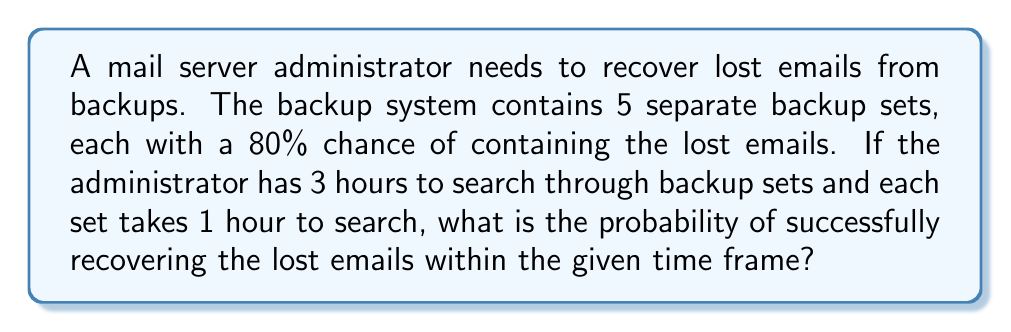Provide a solution to this math problem. Let's approach this step-by-step:

1) The administrator can search through 3 backup sets in the given time frame.

2) The probability of success for each backup set is 80% or 0.8.

3) The probability of failure for each backup set is 1 - 0.8 = 0.2 or 20%.

4) To calculate the probability of success within 3 hours, we need to find the probability of success in at least one of the three backup sets searched.

5) It's easier to calculate the probability of failure in all three sets and then subtract that from 1.

6) The probability of failure in all three sets:
   $$(0.2)^3 = 0.008$$

7) Therefore, the probability of success in at least one of the three sets is:
   $$1 - (0.2)^3 = 1 - 0.008 = 0.992$$

8) Convert to percentage:
   $$0.992 \times 100\% = 99.2\%$$
Answer: 99.2% 